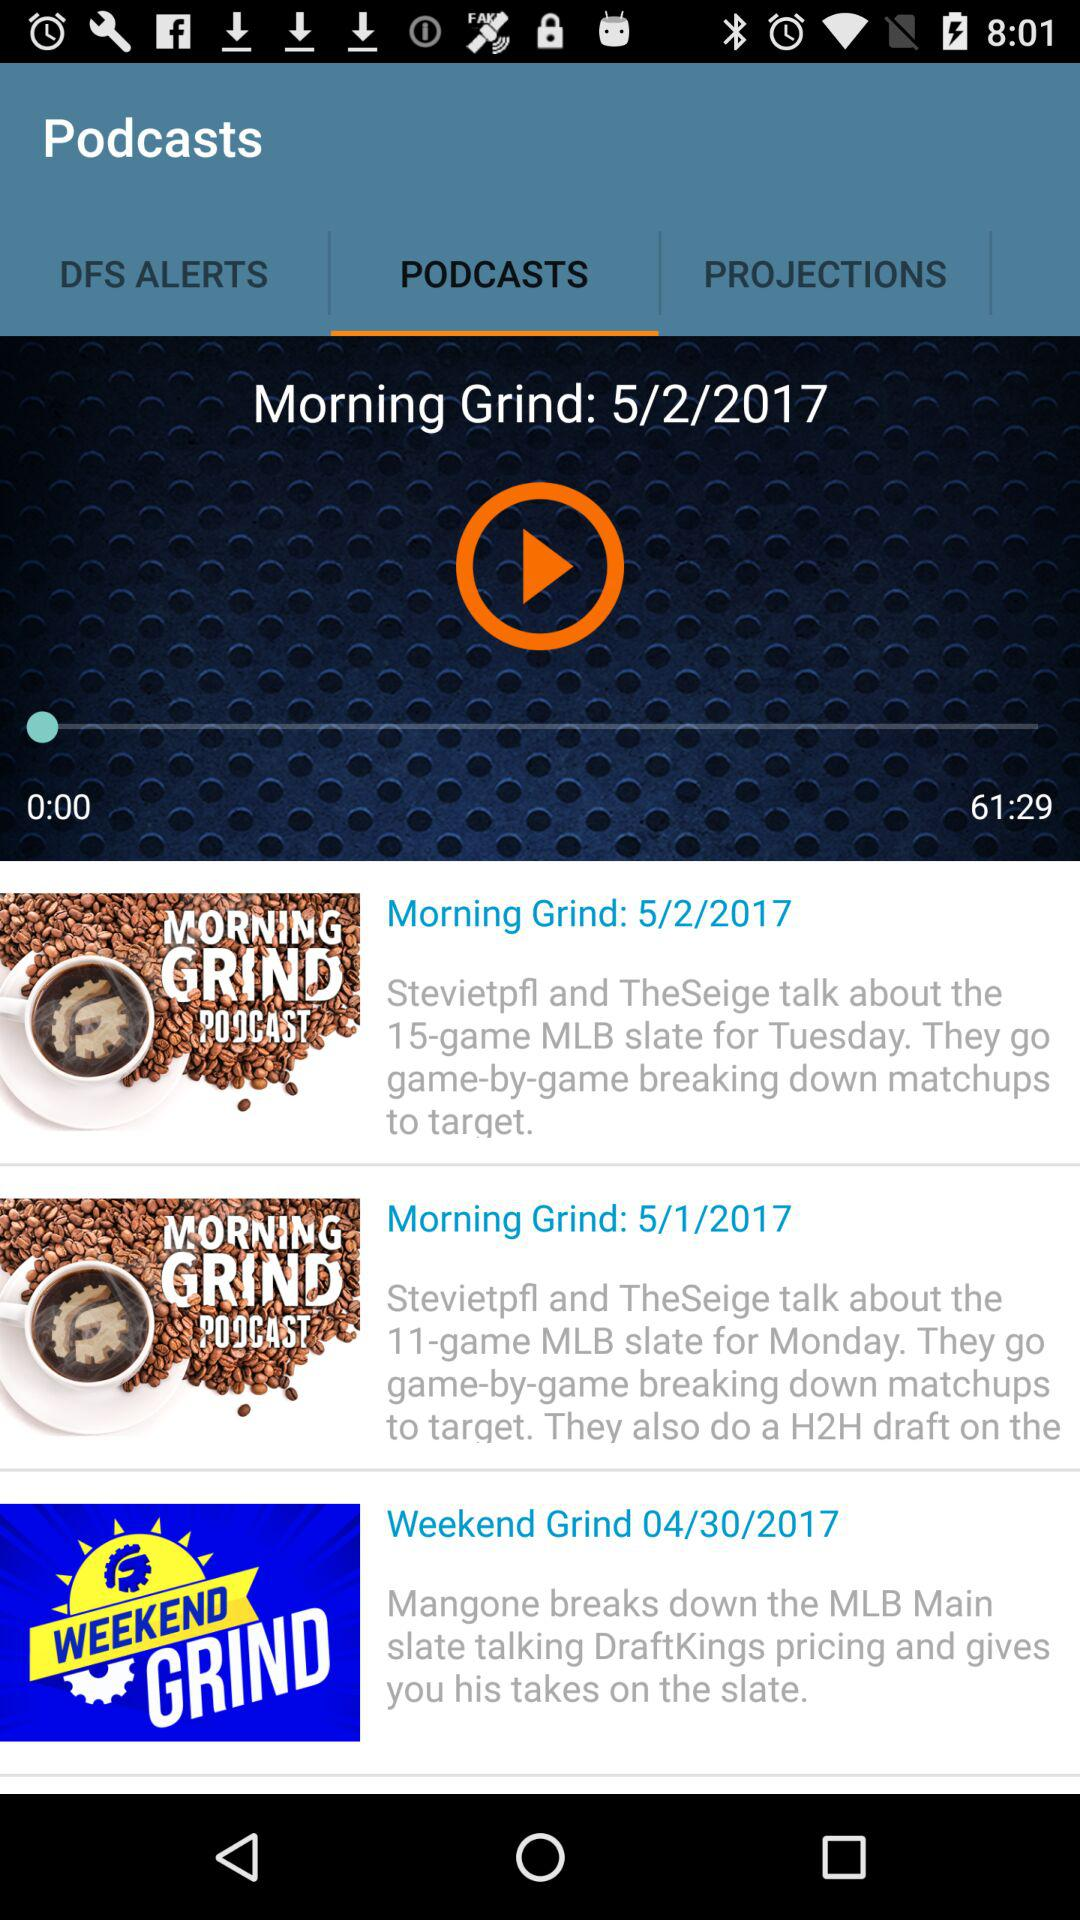How many more minutes are left in the podcast than have already elapsed?
Answer the question using a single word or phrase. 61 